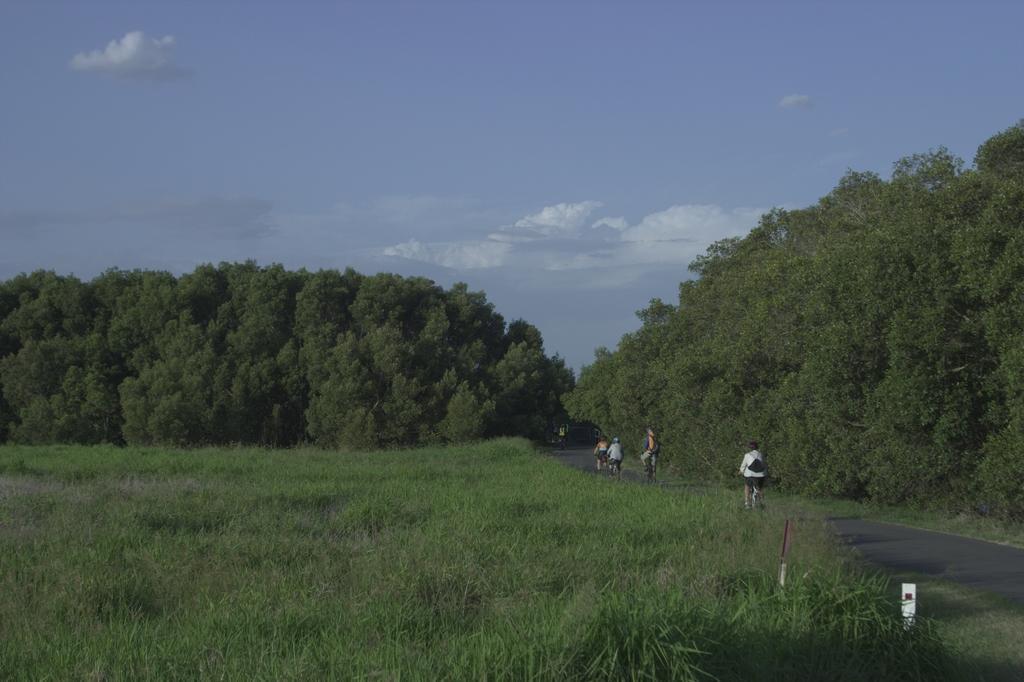Could you give a brief overview of what you see in this image? In this picture in the front there is grass. In the center there are persons. In the background there are trees and the sky is cloudy. 